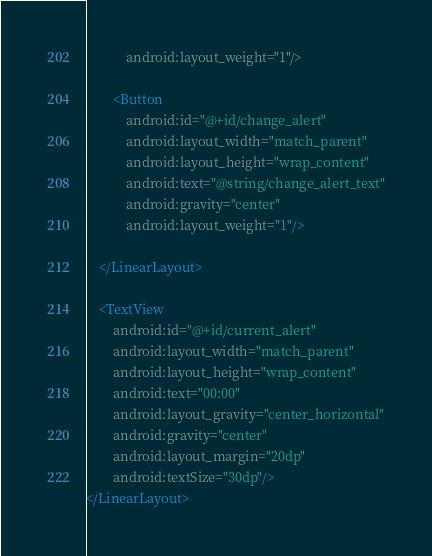Convert code to text. <code><loc_0><loc_0><loc_500><loc_500><_XML_>            android:layout_weight="1"/>

        <Button
            android:id="@+id/change_alert"
            android:layout_width="match_parent"
            android:layout_height="wrap_content"
            android:text="@string/change_alert_text"
            android:gravity="center"
            android:layout_weight="1"/>

    </LinearLayout>

    <TextView
        android:id="@+id/current_alert"
        android:layout_width="match_parent"
        android:layout_height="wrap_content"
        android:text="00:00"
        android:layout_gravity="center_horizontal"
        android:gravity="center"
        android:layout_margin="20dp"
        android:textSize="30dp"/>
</LinearLayout></code> 